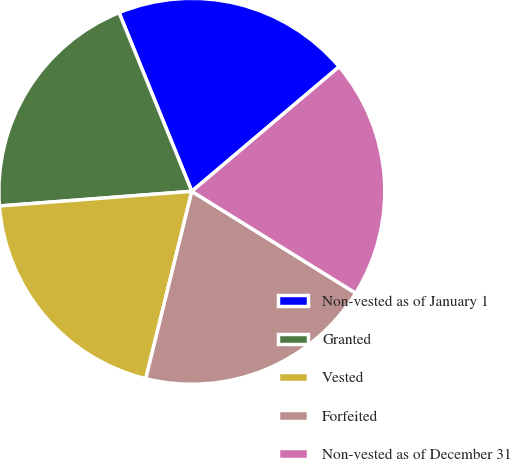<chart> <loc_0><loc_0><loc_500><loc_500><pie_chart><fcel>Non-vested as of January 1<fcel>Granted<fcel>Vested<fcel>Forfeited<fcel>Non-vested as of December 31<nl><fcel>19.98%<fcel>20.06%<fcel>19.95%<fcel>19.99%<fcel>20.03%<nl></chart> 